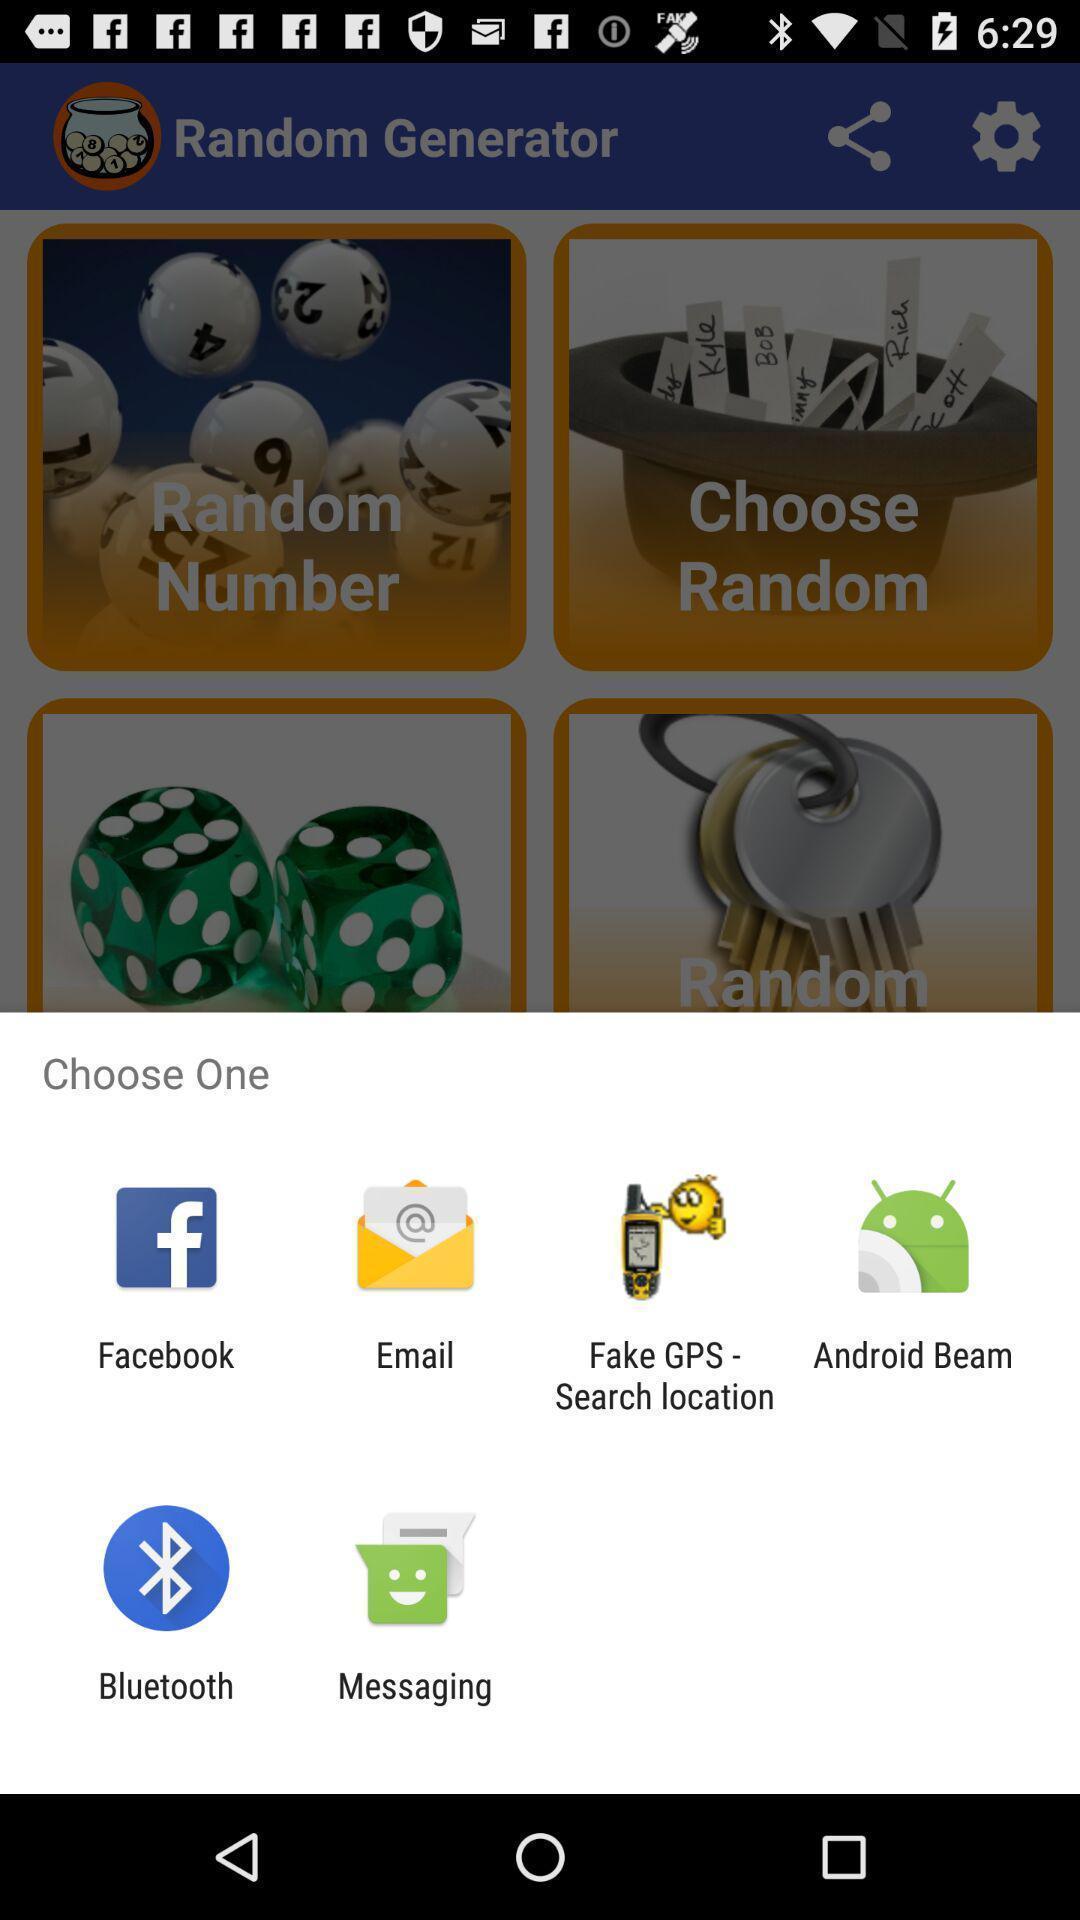Summarize the information in this screenshot. Widget showing different data sharing apps. 